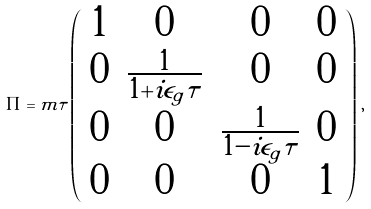<formula> <loc_0><loc_0><loc_500><loc_500>\Pi = m \tau \left ( \begin{array} { c c c c } 1 & 0 & 0 & 0 \\ 0 & \frac { 1 } { 1 + i \epsilon _ { g } \tau } & 0 & 0 \\ 0 & 0 & \frac { 1 } { 1 - i \epsilon _ { g } \tau } & 0 \\ 0 & 0 & 0 & 1 \end{array} \right ) \, ,</formula> 